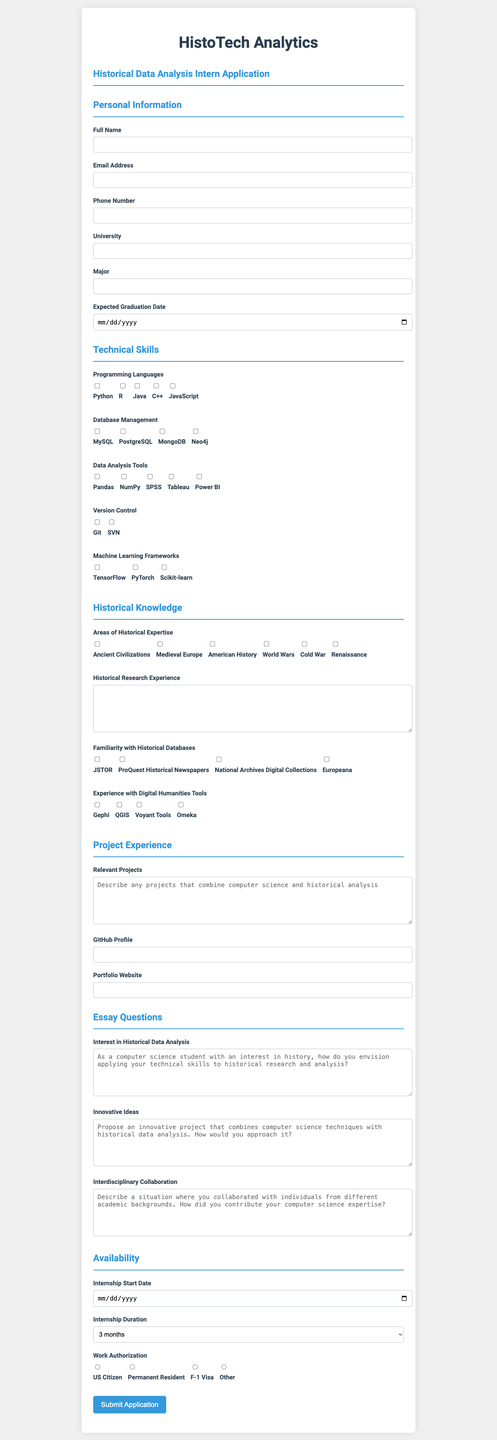What is the name of the company offering the internship? The company name is the first piece of information in the document.
Answer: HistoTech Analytics What is the internship position? The internship position is stated at the top of the application.
Answer: Historical Data Analysis Intern What is the expected graduation date field type? The document lists the type of input required for the expected graduation date.
Answer: date Which programming language is listed as an option under Technical Skills? The options for programming languages are provided as checkboxes in the Technical Skills section.
Answer: Python What section discusses familiarity with historical databases? The section headings in the document indicate the topics covered in each part of the form.
Answer: Historical Knowledge How many options are provided for the Internship Duration? The number of options available in the drop-down selection reflects the choices for internship duration.
Answer: 4 What is one of the innovative project questions mentioned in the Essay Questions section? The document outlines specific questions that are required responses in the application.
Answer: Propose an innovative project that combines computer science techniques with historical data analysis What is the format for the GitHub Profile field? The document specifies the types of input fields included in the form, such as URLs.
Answer: url Which field requires a checkbox selection under Historical Knowledge? There are multiple checkbox fields under the Historical Knowledge section.
Answer: Areas of Historical Expertise 